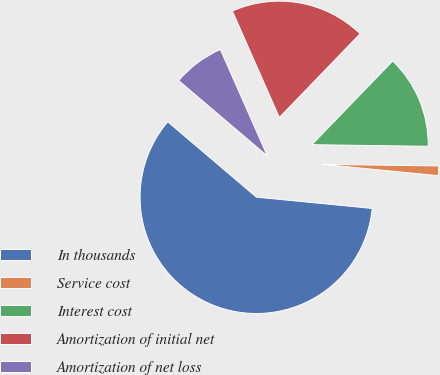<chart> <loc_0><loc_0><loc_500><loc_500><pie_chart><fcel>In thousands<fcel>Service cost<fcel>Interest cost<fcel>Amortization of initial net<fcel>Amortization of net loss<nl><fcel>59.66%<fcel>1.33%<fcel>13.0%<fcel>18.83%<fcel>7.17%<nl></chart> 